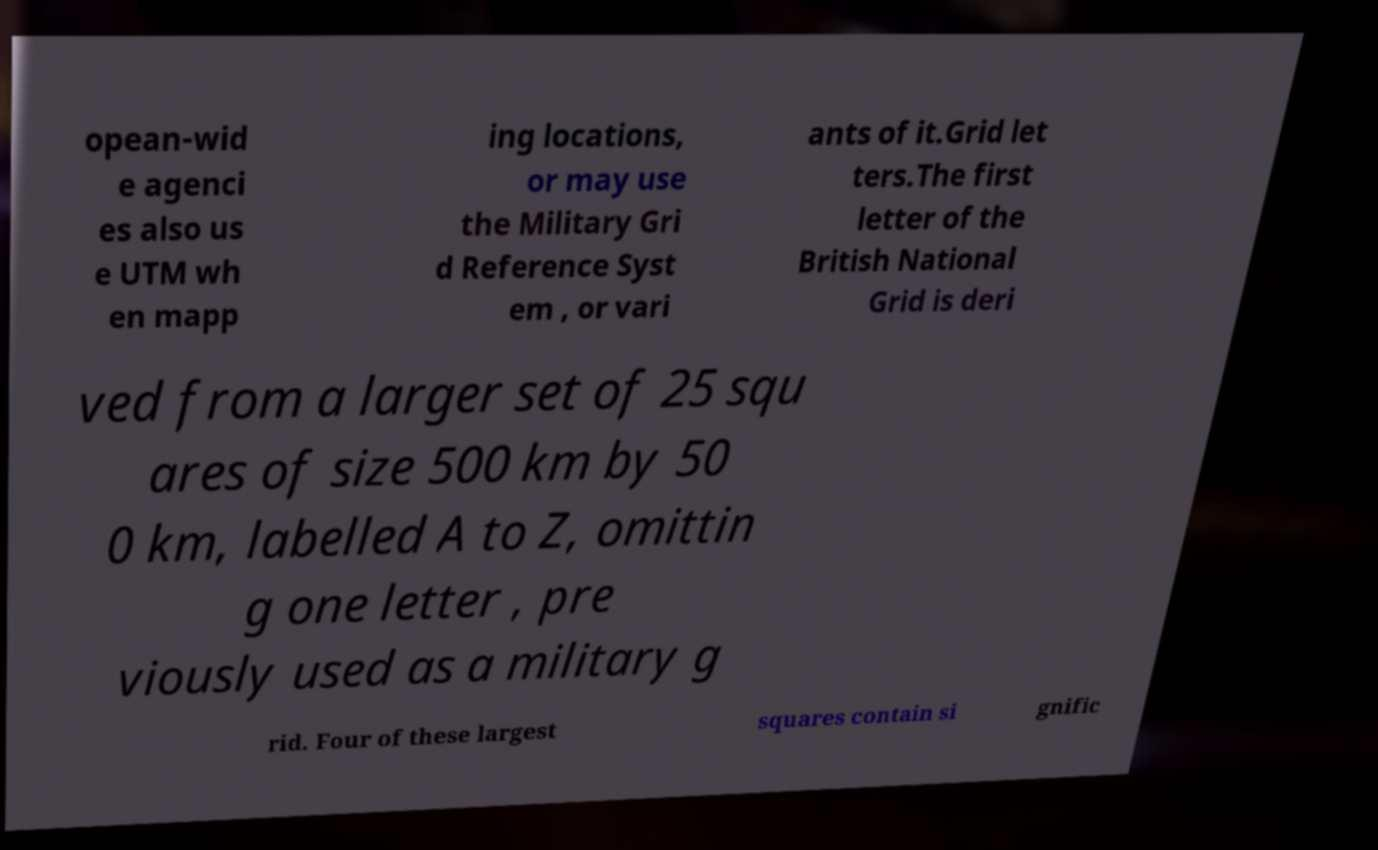I need the written content from this picture converted into text. Can you do that? opean-wid e agenci es also us e UTM wh en mapp ing locations, or may use the Military Gri d Reference Syst em , or vari ants of it.Grid let ters.The first letter of the British National Grid is deri ved from a larger set of 25 squ ares of size 500 km by 50 0 km, labelled A to Z, omittin g one letter , pre viously used as a military g rid. Four of these largest squares contain si gnific 